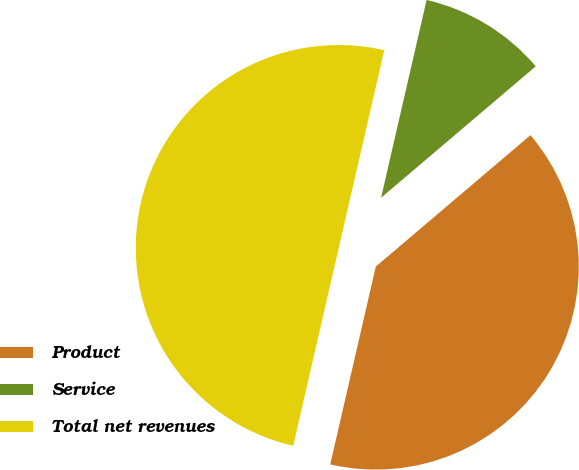Convert chart to OTSL. <chart><loc_0><loc_0><loc_500><loc_500><pie_chart><fcel>Product<fcel>Service<fcel>Total net revenues<nl><fcel>39.81%<fcel>10.19%<fcel>50.0%<nl></chart> 